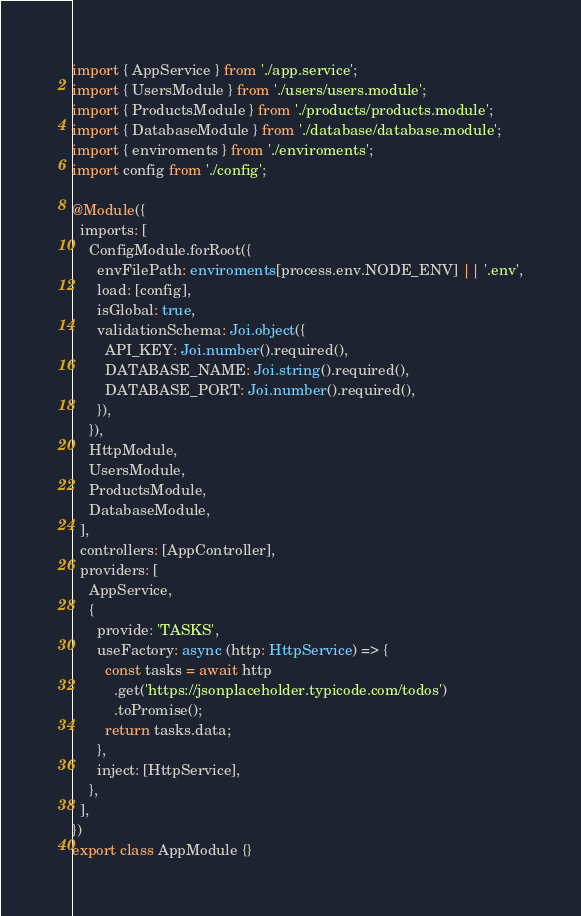<code> <loc_0><loc_0><loc_500><loc_500><_TypeScript_>import { AppService } from './app.service';
import { UsersModule } from './users/users.module';
import { ProductsModule } from './products/products.module';
import { DatabaseModule } from './database/database.module';
import { enviroments } from './enviroments';
import config from './config';

@Module({
  imports: [
    ConfigModule.forRoot({
      envFilePath: enviroments[process.env.NODE_ENV] || '.env',
      load: [config],
      isGlobal: true,
      validationSchema: Joi.object({
        API_KEY: Joi.number().required(),
        DATABASE_NAME: Joi.string().required(),
        DATABASE_PORT: Joi.number().required(),
      }),
    }),
    HttpModule,
    UsersModule,
    ProductsModule,
    DatabaseModule,
  ],
  controllers: [AppController],
  providers: [
    AppService,
    {
      provide: 'TASKS',
      useFactory: async (http: HttpService) => {
        const tasks = await http
          .get('https://jsonplaceholder.typicode.com/todos')
          .toPromise();
        return tasks.data;
      },
      inject: [HttpService],
    },
  ],
})
export class AppModule {}
</code> 